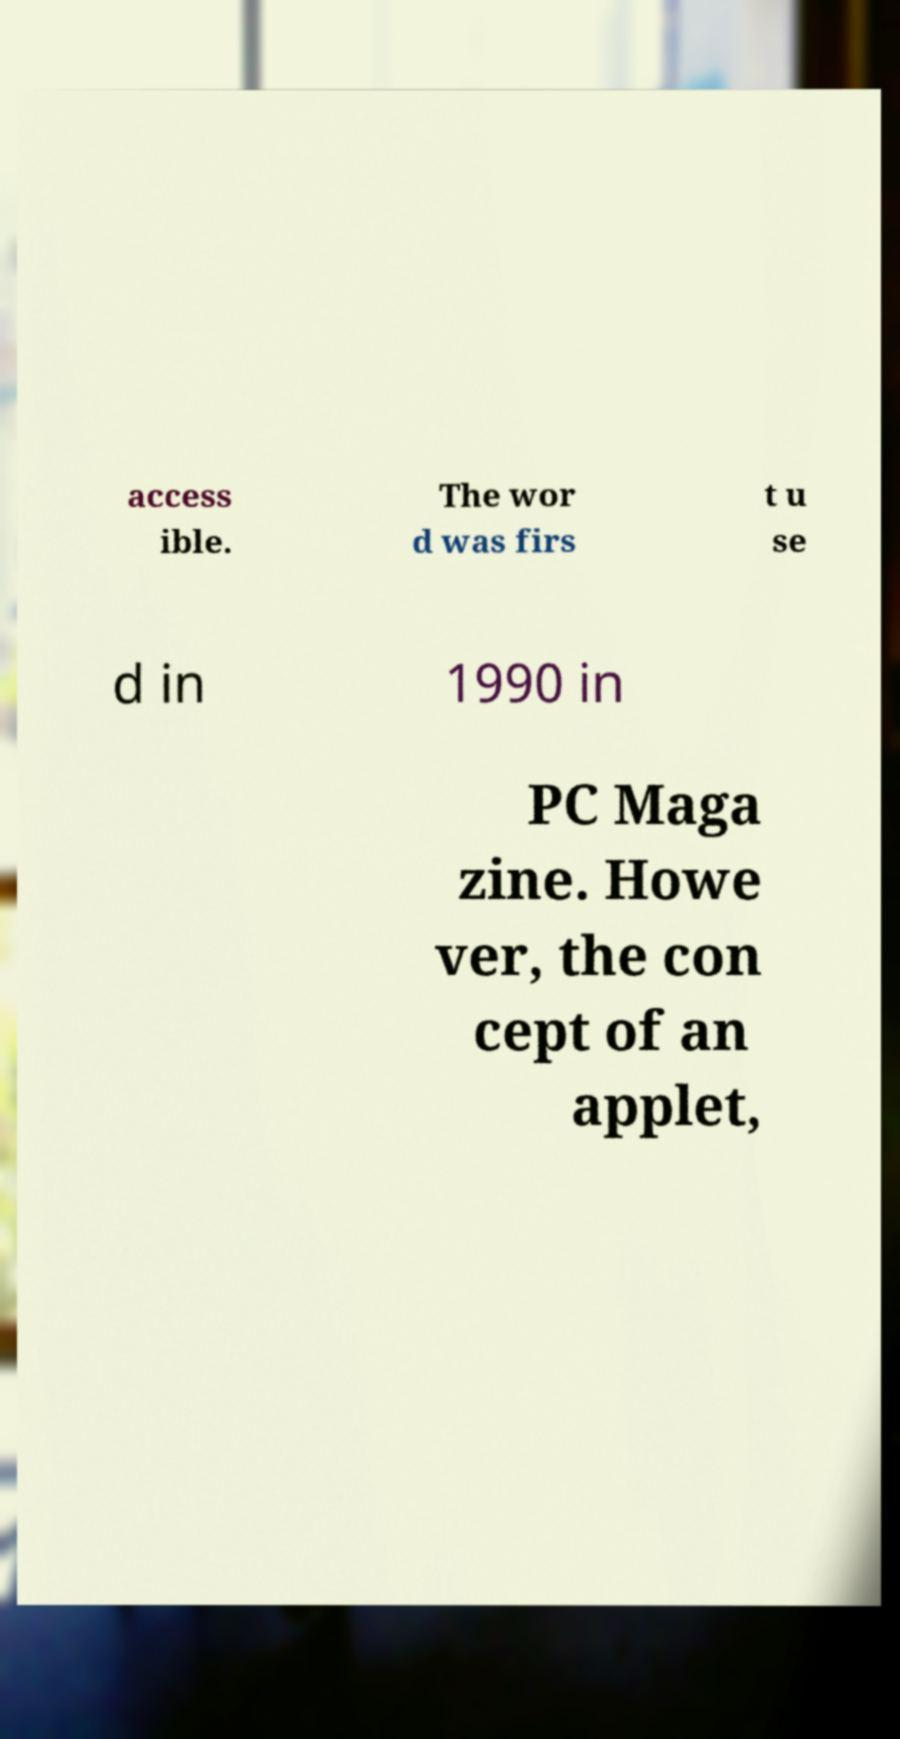What messages or text are displayed in this image? I need them in a readable, typed format. access ible. The wor d was firs t u se d in 1990 in PC Maga zine. Howe ver, the con cept of an applet, 